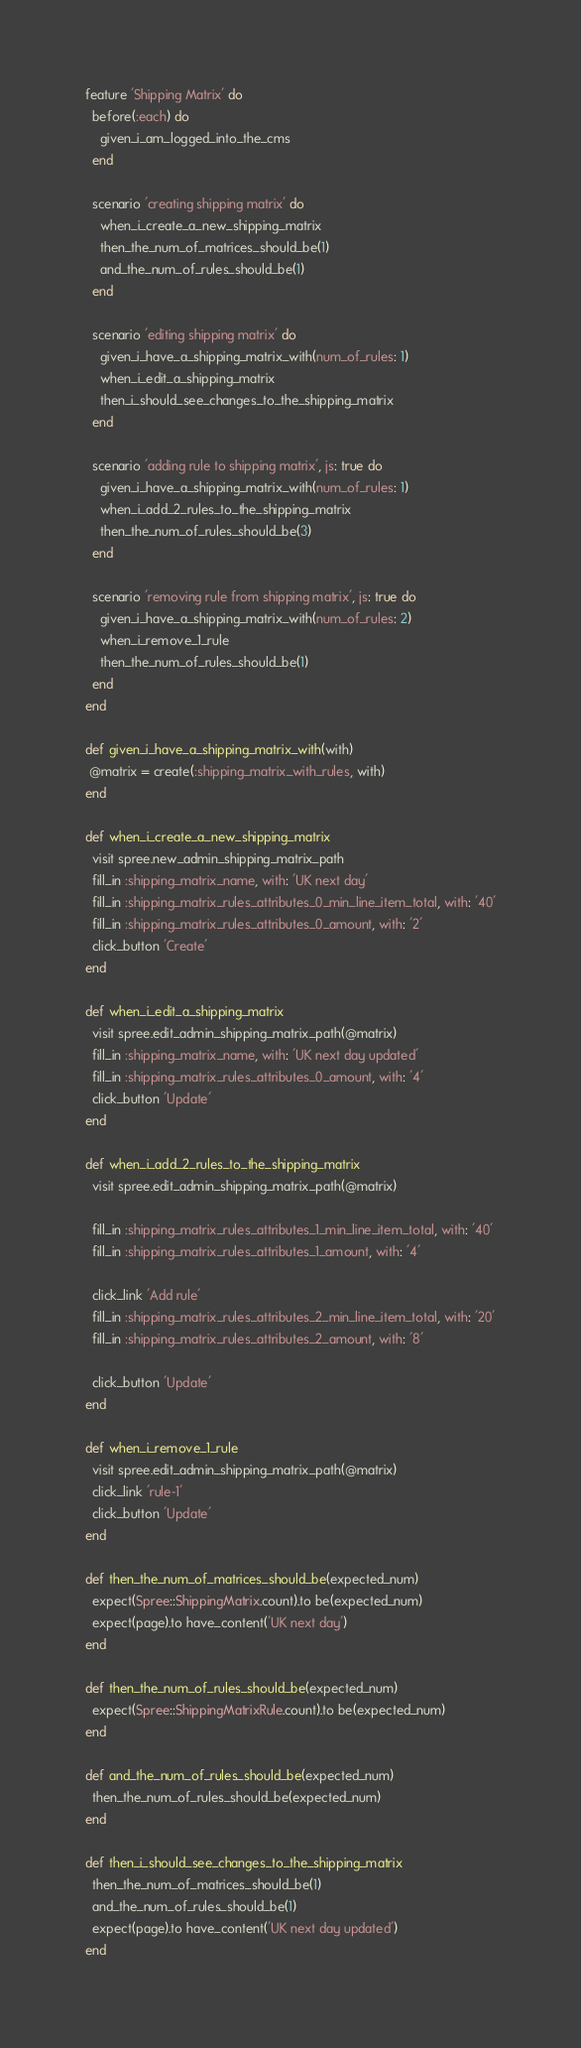Convert code to text. <code><loc_0><loc_0><loc_500><loc_500><_Ruby_>feature 'Shipping Matrix' do
  before(:each) do
    given_i_am_logged_into_the_cms
  end

  scenario 'creating shipping matrix' do
    when_i_create_a_new_shipping_matrix
    then_the_num_of_matrices_should_be(1)
    and_the_num_of_rules_should_be(1)
  end

  scenario 'editing shipping matrix' do
    given_i_have_a_shipping_matrix_with(num_of_rules: 1)
    when_i_edit_a_shipping_matrix
    then_i_should_see_changes_to_the_shipping_matrix
  end

  scenario 'adding rule to shipping matrix', js: true do
    given_i_have_a_shipping_matrix_with(num_of_rules: 1)
    when_i_add_2_rules_to_the_shipping_matrix
    then_the_num_of_rules_should_be(3)
  end

  scenario 'removing rule from shipping matrix', js: true do
    given_i_have_a_shipping_matrix_with(num_of_rules: 2)
    when_i_remove_1_rule
    then_the_num_of_rules_should_be(1)
  end
end

def given_i_have_a_shipping_matrix_with(with)
 @matrix = create(:shipping_matrix_with_rules, with)
end

def when_i_create_a_new_shipping_matrix
  visit spree.new_admin_shipping_matrix_path
  fill_in :shipping_matrix_name, with: 'UK next day'
  fill_in :shipping_matrix_rules_attributes_0_min_line_item_total, with: '40'
  fill_in :shipping_matrix_rules_attributes_0_amount, with: '2'
  click_button 'Create'
end

def when_i_edit_a_shipping_matrix
  visit spree.edit_admin_shipping_matrix_path(@matrix)
  fill_in :shipping_matrix_name, with: 'UK next day updated'
  fill_in :shipping_matrix_rules_attributes_0_amount, with: '4'
  click_button 'Update'
end

def when_i_add_2_rules_to_the_shipping_matrix
  visit spree.edit_admin_shipping_matrix_path(@matrix)

  fill_in :shipping_matrix_rules_attributes_1_min_line_item_total, with: '40'
  fill_in :shipping_matrix_rules_attributes_1_amount, with: '4'

  click_link 'Add rule'
  fill_in :shipping_matrix_rules_attributes_2_min_line_item_total, with: '20'
  fill_in :shipping_matrix_rules_attributes_2_amount, with: '8'

  click_button 'Update'
end

def when_i_remove_1_rule
  visit spree.edit_admin_shipping_matrix_path(@matrix)
  click_link 'rule-1'
  click_button 'Update'
end

def then_the_num_of_matrices_should_be(expected_num)
  expect(Spree::ShippingMatrix.count).to be(expected_num)
  expect(page).to have_content('UK next day')
end

def then_the_num_of_rules_should_be(expected_num)
  expect(Spree::ShippingMatrixRule.count).to be(expected_num)
end

def and_the_num_of_rules_should_be(expected_num)
  then_the_num_of_rules_should_be(expected_num)
end

def then_i_should_see_changes_to_the_shipping_matrix
  then_the_num_of_matrices_should_be(1)
  and_the_num_of_rules_should_be(1)
  expect(page).to have_content('UK next day updated')
end
</code> 